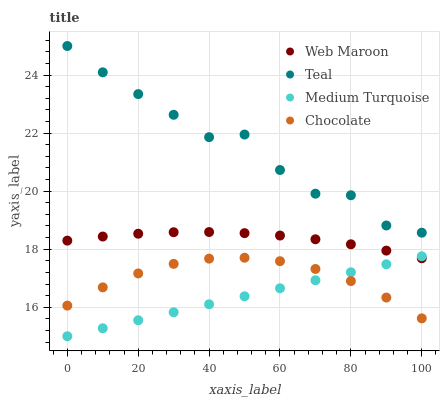Does Medium Turquoise have the minimum area under the curve?
Answer yes or no. Yes. Does Teal have the maximum area under the curve?
Answer yes or no. Yes. Does Teal have the minimum area under the curve?
Answer yes or no. No. Does Medium Turquoise have the maximum area under the curve?
Answer yes or no. No. Is Medium Turquoise the smoothest?
Answer yes or no. Yes. Is Teal the roughest?
Answer yes or no. Yes. Is Teal the smoothest?
Answer yes or no. No. Is Medium Turquoise the roughest?
Answer yes or no. No. Does Medium Turquoise have the lowest value?
Answer yes or no. Yes. Does Teal have the lowest value?
Answer yes or no. No. Does Teal have the highest value?
Answer yes or no. Yes. Does Medium Turquoise have the highest value?
Answer yes or no. No. Is Medium Turquoise less than Teal?
Answer yes or no. Yes. Is Teal greater than Web Maroon?
Answer yes or no. Yes. Does Medium Turquoise intersect Web Maroon?
Answer yes or no. Yes. Is Medium Turquoise less than Web Maroon?
Answer yes or no. No. Is Medium Turquoise greater than Web Maroon?
Answer yes or no. No. Does Medium Turquoise intersect Teal?
Answer yes or no. No. 